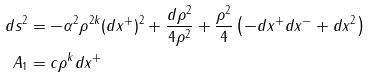<formula> <loc_0><loc_0><loc_500><loc_500>d s ^ { 2 } & = - \alpha ^ { 2 } \rho ^ { 2 k } ( d x ^ { + } ) ^ { 2 } + \frac { d \rho ^ { 2 } } { 4 \rho ^ { 2 } } + \frac { \rho ^ { 2 } } { 4 } \left ( - d x ^ { + } d x ^ { - } + d x ^ { 2 } \right ) \\ A _ { 1 } & = c \rho ^ { k } d x ^ { + }</formula> 